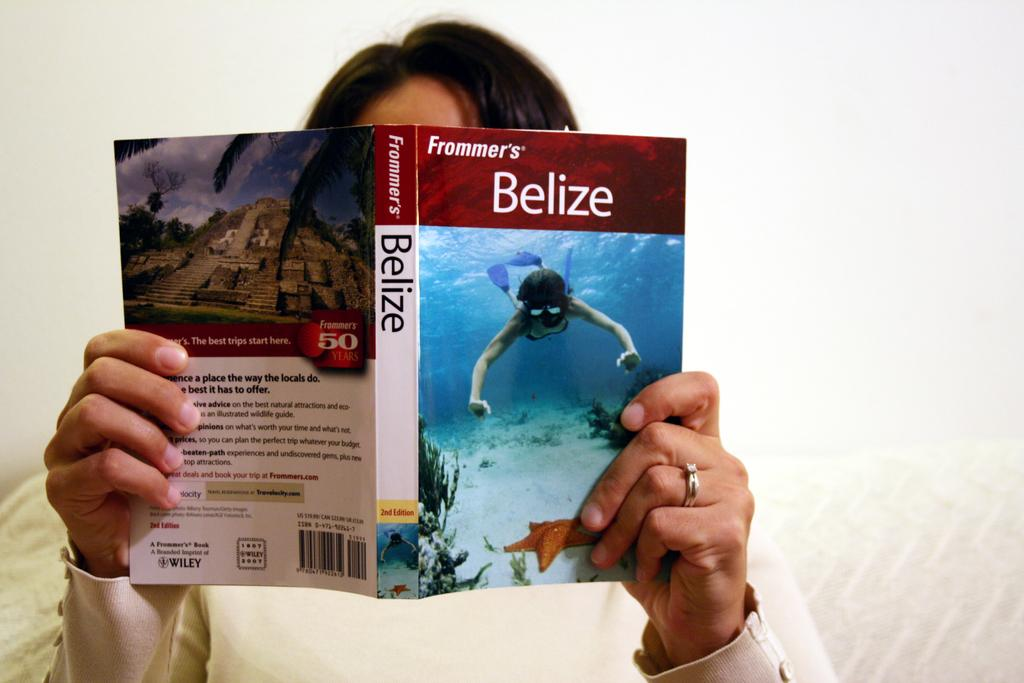Provide a one-sentence caption for the provided image. a book that has the name Belize written on it. 